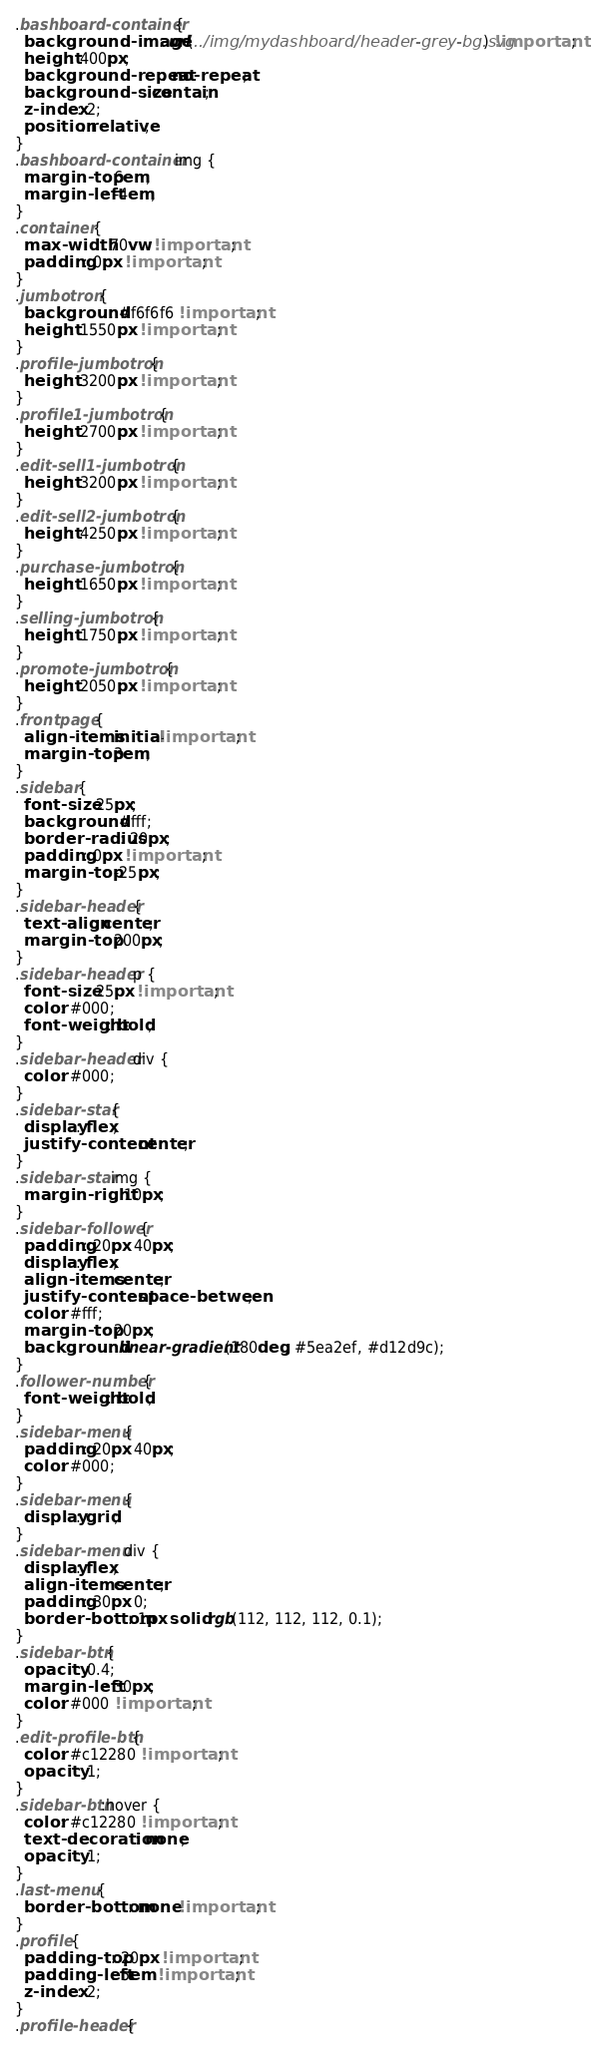<code> <loc_0><loc_0><loc_500><loc_500><_CSS_>.bashboard-container {
  background-image: url(../img/mydashboard/header-grey-bg.svg) !important;
  height: 400px;
  background-repeat: no-repeat;
  background-size: contain;
  z-index: 2;
  position: relative;
}
.bashboard-container img {
  margin-top: 6em;
  margin-left: -4em;
}
.container {
  max-width: 70vw !important;
  padding: 0px !important;
}
.jumbotron {
  background: #f6f6f6 !important;
  height: 1550px !important;
}
.profile-jumbotron {
  height: 3200px !important;
}
.profile1-jumbotron {
  height: 2700px !important;
}
.edit-sell1-jumbotron {
  height: 3200px !important;
}
.edit-sell2-jumbotron {
  height: 4250px !important;
}
.purchase-jumbotron {
  height: 1650px !important;
}
.selling-jumbotron {
  height: 1750px !important;
}
.promote-jumbotron {
  height: 2050px !important;
}
.frontpage {
  align-items: initial !important;
  margin-top: 3em;
}
.sidebar {
  font-size: 25px;
  background: #fff;
  border-radius: 20px;
  padding: 0px !important;
  margin-top: -25px;
}
.sidebar-header {
  text-align: center;
  margin-top: 200px;
}
.sidebar-header p {
  font-size: 25px !important;
  color: #000;
  font-weight: bold;
}
.sidebar-header div {
  color: #000;
}
.sidebar-star {
  display: flex;
  justify-content: center;
}
.sidebar-star img {
  margin-right: 10px;
}
.sidebar-follower {
  padding: 20px 40px;
  display: flex;
  align-items: center;
  justify-content: space-between;
  color: #fff;
  margin-top: 20px;
  background: linear-gradient(180deg, #5ea2ef, #d12d9c);
}
.follower-number {
  font-weight: bold;
}
.sidebar-menu {
  padding: 20px 40px;
  color: #000;
}
.sidebar-menu {
  display: grid;
}
.sidebar-menu div {
  display: flex;
  align-items: center;
  padding: 30px 0;
  border-bottom: 1px solid rgb(112, 112, 112, 0.1);
}
.sidebar-btn {
  opacity: 0.4;
  margin-left: 30px;
  color: #000 !important;
}
.edit-profile-btn {
  color: #c12280 !important;
  opacity: 1;
}
.sidebar-btn:hover {
  color: #c12280 !important;
  text-decoration: none;
  opacity: 1;
}
.last-menu {
  border-bottom: none !important;
}
.profile {
  padding-top: 20px !important;
  padding-left: 5em !important;
  z-index: 2;
}
.profile-header {</code> 